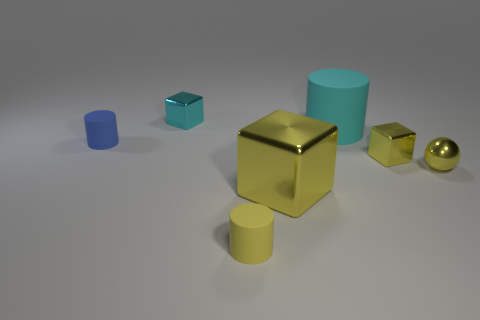Is the number of rubber objects on the left side of the big matte object the same as the number of cyan shiny cubes in front of the small blue object?
Give a very brief answer. No. Does the tiny cylinder in front of the yellow ball have the same material as the big cylinder?
Your answer should be compact. Yes. There is a object that is both to the right of the big yellow thing and behind the tiny blue thing; what color is it?
Make the answer very short. Cyan. There is a cylinder that is in front of the blue matte cylinder; what number of blue cylinders are on the left side of it?
Provide a succinct answer. 1. What material is the yellow object that is the same shape as the big cyan thing?
Your response must be concise. Rubber. The big matte cylinder is what color?
Ensure brevity in your answer.  Cyan. How many objects are either small red metal things or yellow shiny balls?
Your answer should be very brief. 1. The small yellow object that is on the left side of the rubber object that is on the right side of the yellow cylinder is what shape?
Keep it short and to the point. Cylinder. What number of other things are the same material as the small ball?
Give a very brief answer. 3. Is the large block made of the same material as the cylinder in front of the blue object?
Make the answer very short. No. 